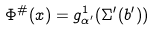<formula> <loc_0><loc_0><loc_500><loc_500>\Phi ^ { \# } ( x ) = g ^ { 1 } _ { \alpha ^ { \prime } } ( \Sigma ^ { \prime } ( b ^ { \prime } ) )</formula> 